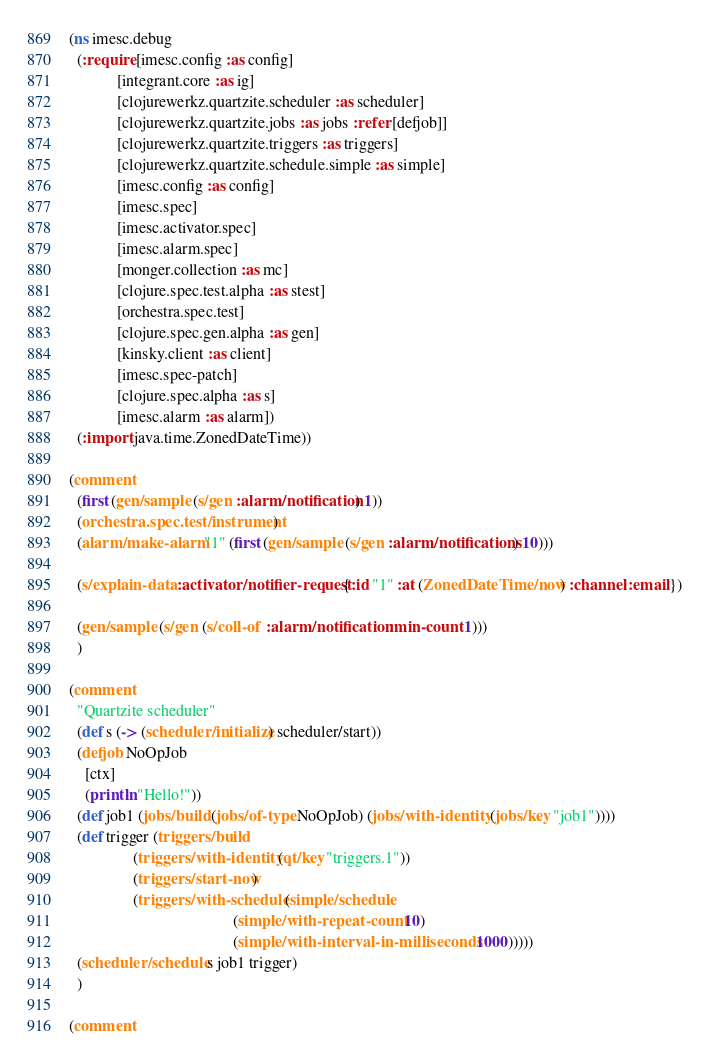Convert code to text. <code><loc_0><loc_0><loc_500><loc_500><_Clojure_>(ns imesc.debug
  (:require [imesc.config :as config]
            [integrant.core :as ig]
            [clojurewerkz.quartzite.scheduler :as scheduler]
            [clojurewerkz.quartzite.jobs :as jobs :refer [defjob]]
            [clojurewerkz.quartzite.triggers :as triggers]
            [clojurewerkz.quartzite.schedule.simple :as simple]
            [imesc.config :as config]
            [imesc.spec]
            [imesc.activator.spec]
            [imesc.alarm.spec]
            [monger.collection :as mc]
            [clojure.spec.test.alpha :as stest]
            [orchestra.spec.test]
            [clojure.spec.gen.alpha :as gen]
            [kinsky.client :as client]
            [imesc.spec-patch]
            [clojure.spec.alpha :as s]
            [imesc.alarm :as alarm])
  (:import java.time.ZonedDateTime))

(comment
  (first (gen/sample (s/gen :alarm/notification) 1))
  (orchestra.spec.test/instrument)
  (alarm/make-alarm "1" (first (gen/sample (s/gen :alarm/notifications) 10)))

  (s/explain-data :activator/notifier-request {:id "1" :at (ZonedDateTime/now) :channel :email})

  (gen/sample (s/gen (s/coll-of :alarm/notification :min-count 1)))
  )

(comment
  "Quartzite scheduler"
  (def s (-> (scheduler/initialize) scheduler/start))
  (defjob NoOpJob
    [ctx]
    (println "Hello!"))
  (def job1 (jobs/build (jobs/of-type NoOpJob) (jobs/with-identity (jobs/key "job1"))))
  (def trigger (triggers/build
                (triggers/with-identity (qt/key "triggers.1"))
                (triggers/start-now)
                (triggers/with-schedule (simple/schedule
                                         (simple/with-repeat-count 10)
                                         (simple/with-interval-in-milliseconds 1000)))))
  (scheduler/schedule s job1 trigger)
  )

(comment</code> 